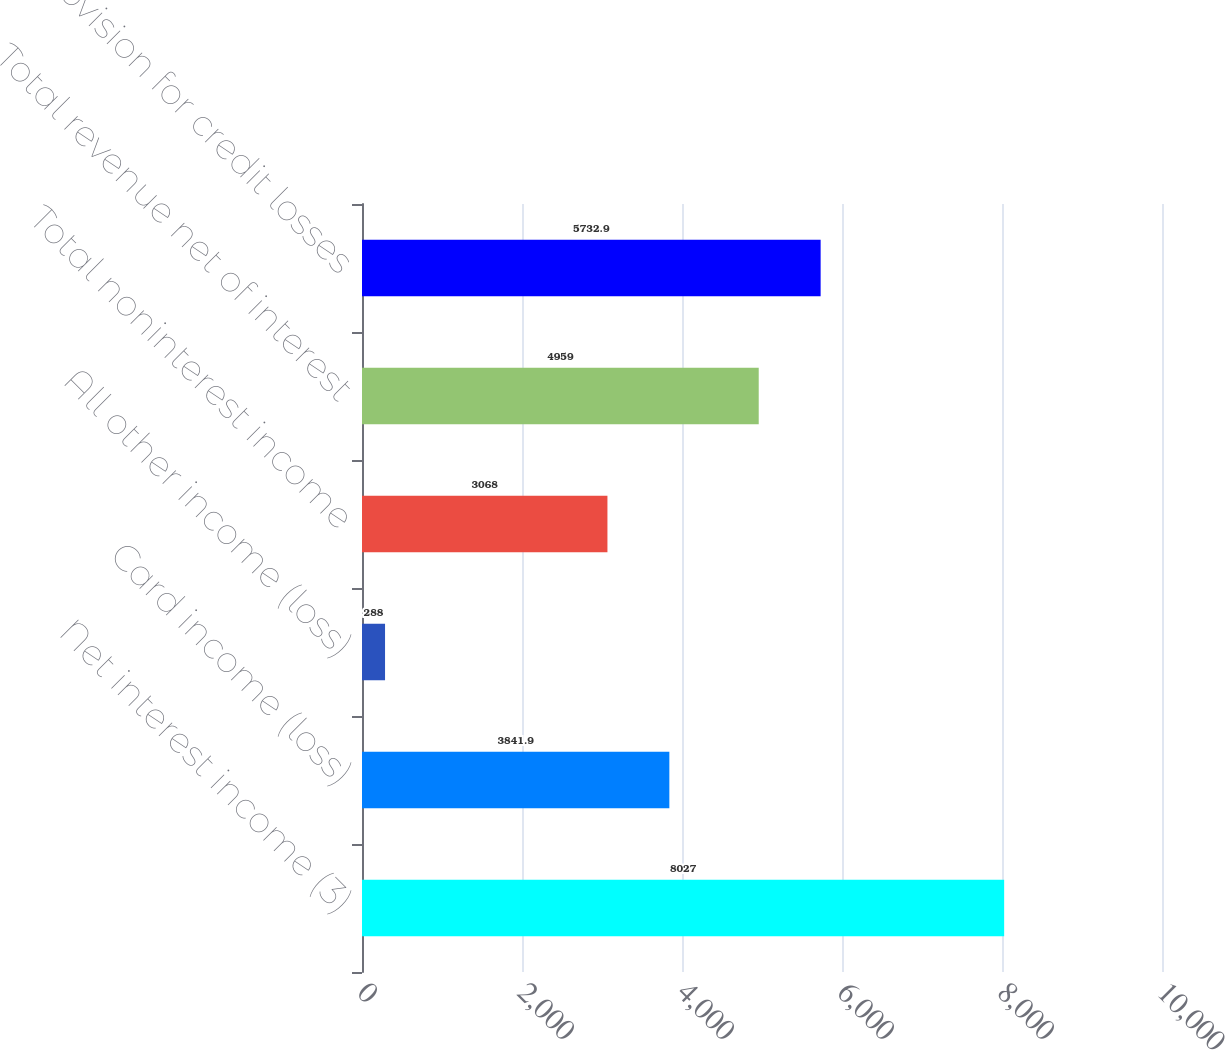Convert chart. <chart><loc_0><loc_0><loc_500><loc_500><bar_chart><fcel>Net interest income (3)<fcel>Card income (loss)<fcel>All other income (loss)<fcel>Total noninterest income<fcel>Total revenue net of interest<fcel>Provision for credit losses<nl><fcel>8027<fcel>3841.9<fcel>288<fcel>3068<fcel>4959<fcel>5732.9<nl></chart> 